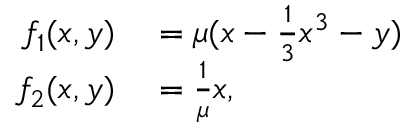<formula> <loc_0><loc_0><loc_500><loc_500>\begin{array} { r l } { f _ { 1 } ( x , y ) } & = \mu ( x - \frac { 1 } { 3 } x ^ { 3 } - y ) } \\ { f _ { 2 } ( x , y ) } & = \frac { 1 } { \mu } x , } \end{array}</formula> 